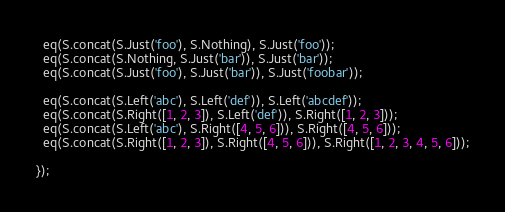Convert code to text. <code><loc_0><loc_0><loc_500><loc_500><_JavaScript_>  eq(S.concat(S.Just('foo'), S.Nothing), S.Just('foo'));
  eq(S.concat(S.Nothing, S.Just('bar')), S.Just('bar'));
  eq(S.concat(S.Just('foo'), S.Just('bar')), S.Just('foobar'));

  eq(S.concat(S.Left('abc'), S.Left('def')), S.Left('abcdef'));
  eq(S.concat(S.Right([1, 2, 3]), S.Left('def')), S.Right([1, 2, 3]));
  eq(S.concat(S.Left('abc'), S.Right([4, 5, 6])), S.Right([4, 5, 6]));
  eq(S.concat(S.Right([1, 2, 3]), S.Right([4, 5, 6])), S.Right([1, 2, 3, 4, 5, 6]));

});
</code> 